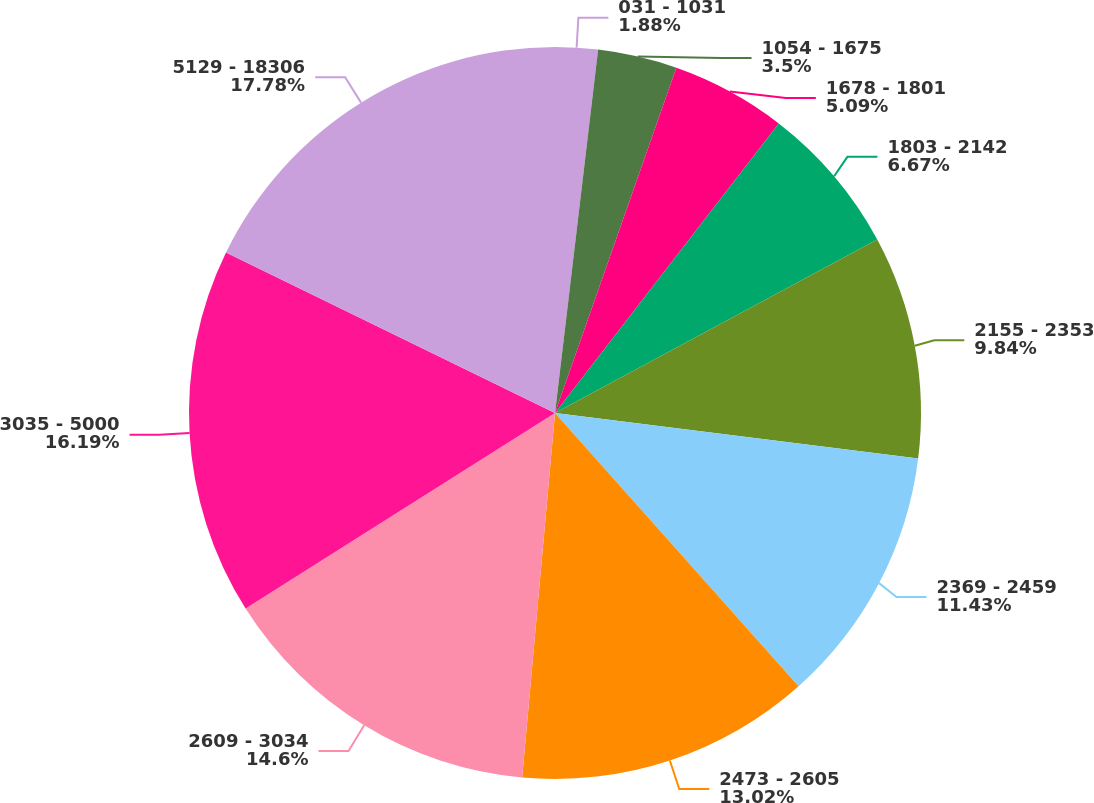<chart> <loc_0><loc_0><loc_500><loc_500><pie_chart><fcel>031 - 1031<fcel>1054 - 1675<fcel>1678 - 1801<fcel>1803 - 2142<fcel>2155 - 2353<fcel>2369 - 2459<fcel>2473 - 2605<fcel>2609 - 3034<fcel>3035 - 5000<fcel>5129 - 18306<nl><fcel>1.88%<fcel>3.5%<fcel>5.09%<fcel>6.67%<fcel>9.84%<fcel>11.43%<fcel>13.02%<fcel>14.6%<fcel>16.19%<fcel>17.78%<nl></chart> 